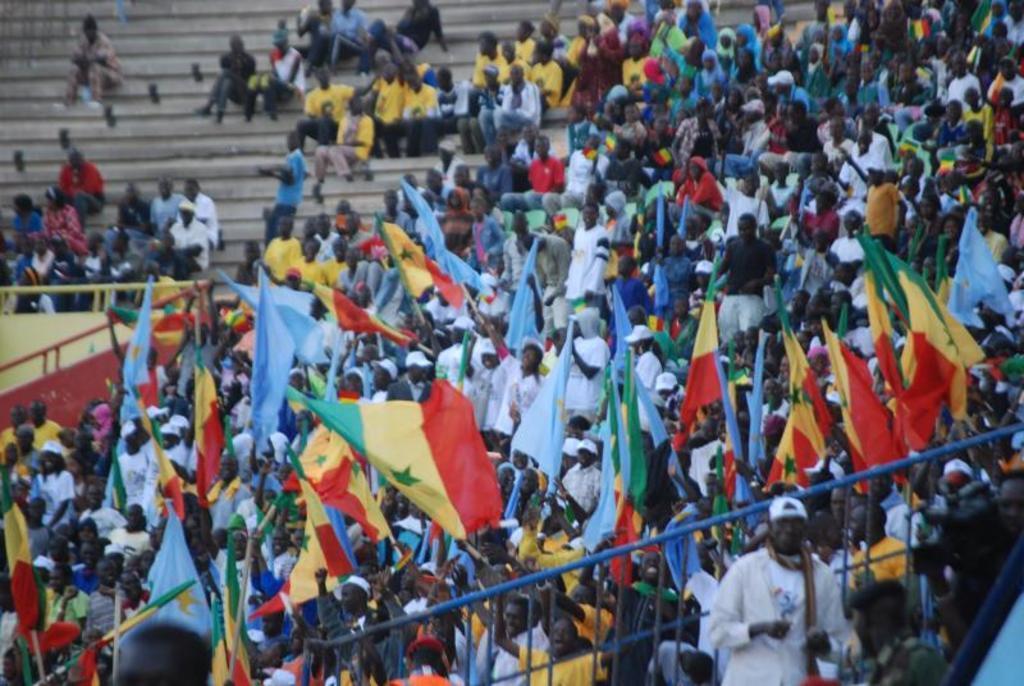In one or two sentences, can you explain what this image depicts? In this image we can see there are few people standing and few people sitting on the stairs and holding flags. And we can see there is a fence and an object. 